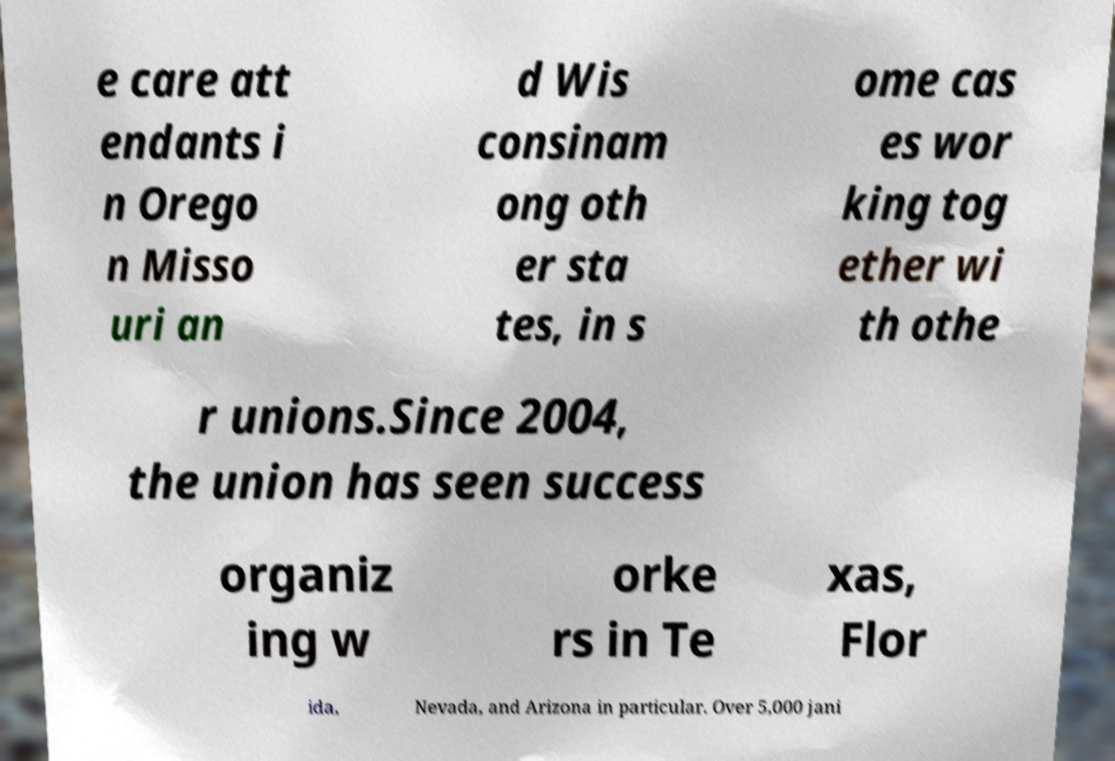I need the written content from this picture converted into text. Can you do that? e care att endants i n Orego n Misso uri an d Wis consinam ong oth er sta tes, in s ome cas es wor king tog ether wi th othe r unions.Since 2004, the union has seen success organiz ing w orke rs in Te xas, Flor ida, Nevada, and Arizona in particular. Over 5,000 jani 